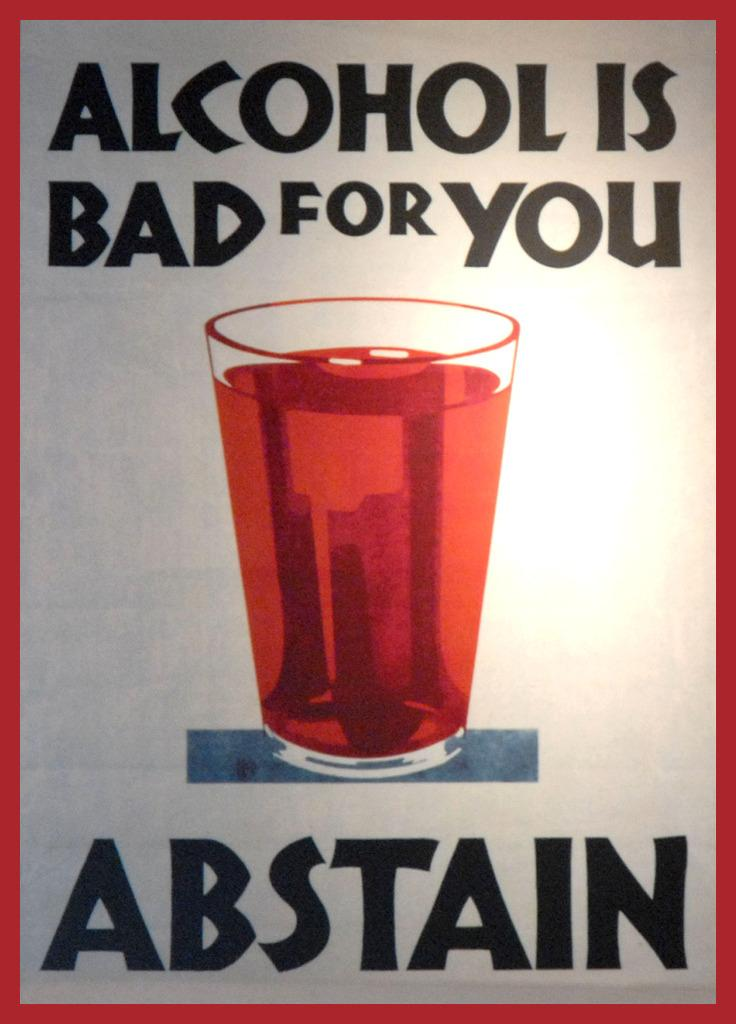<image>
Present a compact description of the photo's key features. poster with red trim, glass with red liquid in center and words alcohol is bad for you at top and abstain at bottom 